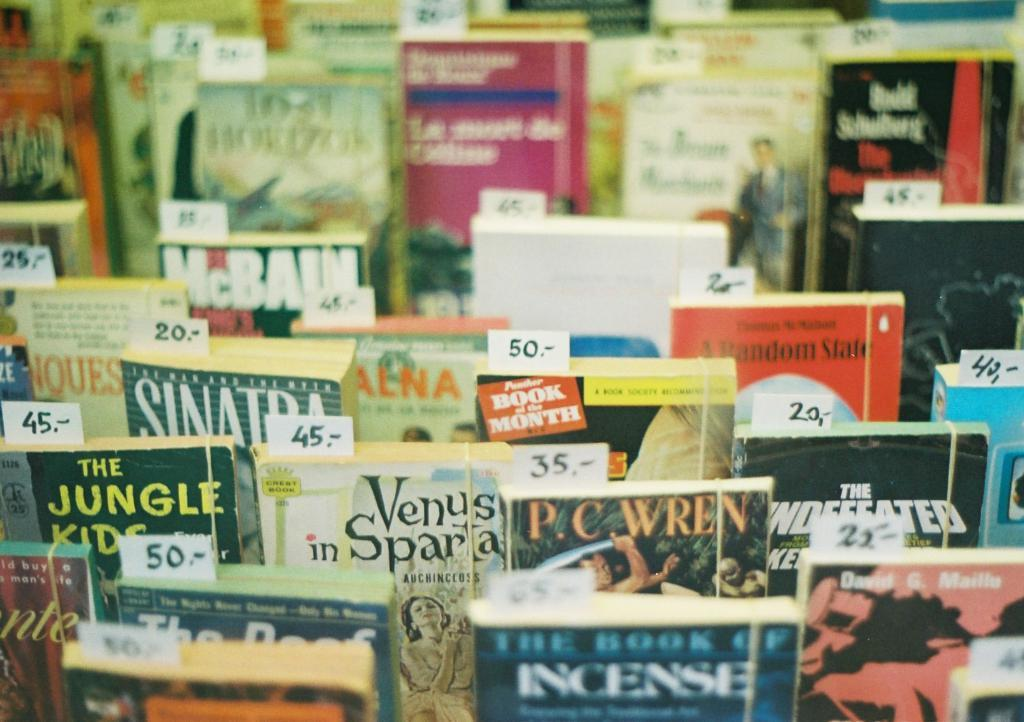<image>
Share a concise interpretation of the image provided. Several books are shown, including "The Book of Incense." 